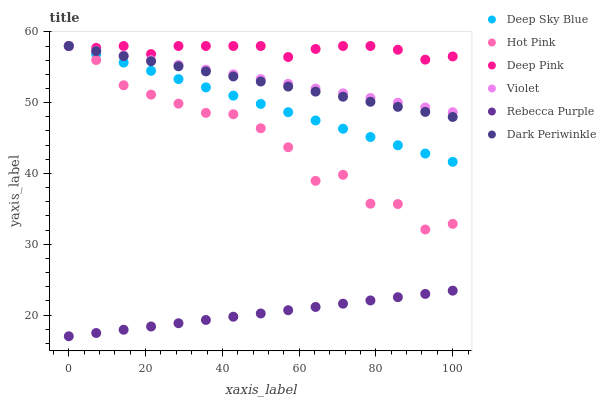Does Rebecca Purple have the minimum area under the curve?
Answer yes or no. Yes. Does Deep Pink have the maximum area under the curve?
Answer yes or no. Yes. Does Hot Pink have the minimum area under the curve?
Answer yes or no. No. Does Hot Pink have the maximum area under the curve?
Answer yes or no. No. Is Violet the smoothest?
Answer yes or no. Yes. Is Hot Pink the roughest?
Answer yes or no. Yes. Is Rebecca Purple the smoothest?
Answer yes or no. No. Is Rebecca Purple the roughest?
Answer yes or no. No. Does Rebecca Purple have the lowest value?
Answer yes or no. Yes. Does Hot Pink have the lowest value?
Answer yes or no. No. Does Dark Periwinkle have the highest value?
Answer yes or no. Yes. Does Rebecca Purple have the highest value?
Answer yes or no. No. Is Rebecca Purple less than Deep Sky Blue?
Answer yes or no. Yes. Is Deep Sky Blue greater than Rebecca Purple?
Answer yes or no. Yes. Does Violet intersect Dark Periwinkle?
Answer yes or no. Yes. Is Violet less than Dark Periwinkle?
Answer yes or no. No. Is Violet greater than Dark Periwinkle?
Answer yes or no. No. Does Rebecca Purple intersect Deep Sky Blue?
Answer yes or no. No. 